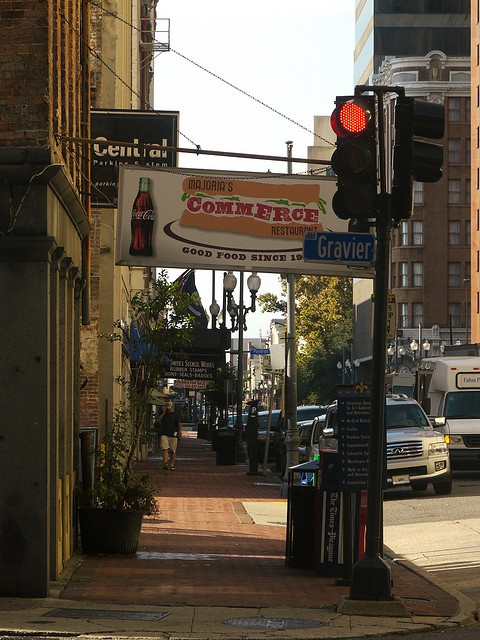Describe the objects in this image and their specific colors. I can see potted plant in black, olive, and gray tones, traffic light in black, maroon, red, and gray tones, bus in black, darkgray, gray, and tan tones, car in black, gray, darkgray, and tan tones, and bottle in black, maroon, and gray tones in this image. 